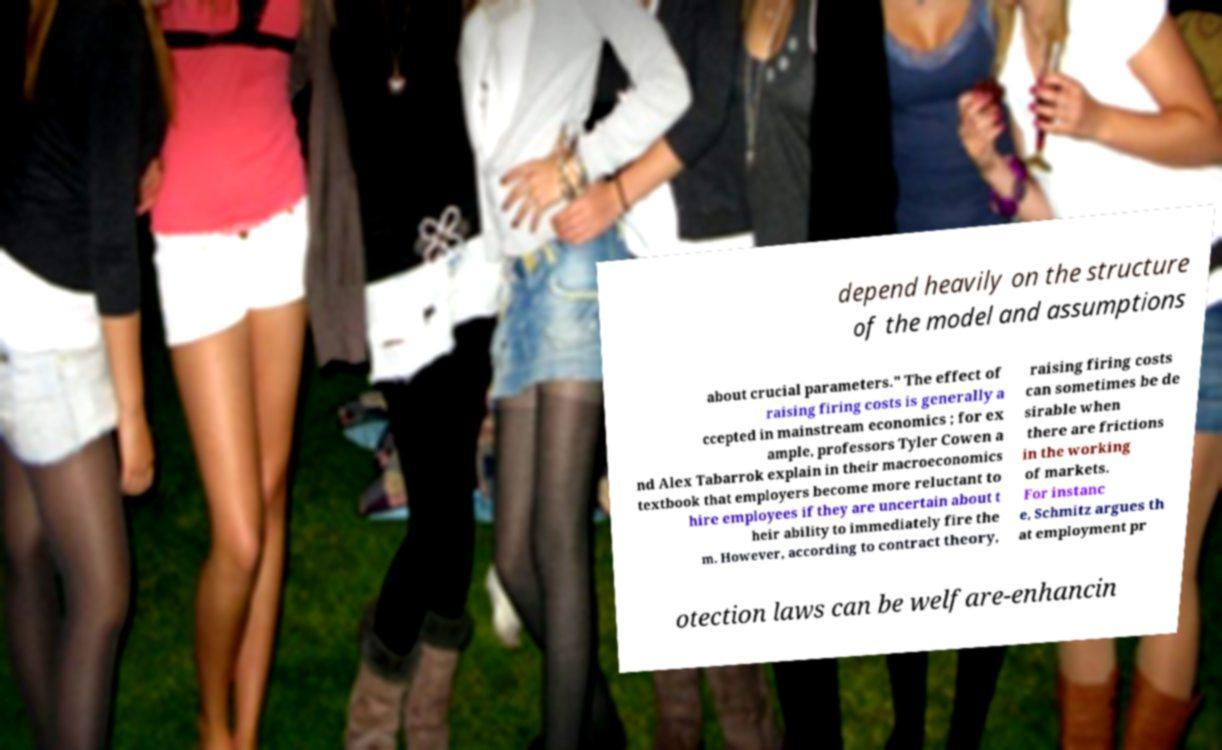What messages or text are displayed in this image? I need them in a readable, typed format. depend heavily on the structure of the model and assumptions about crucial parameters." The effect of raising firing costs is generally a ccepted in mainstream economics ; for ex ample, professors Tyler Cowen a nd Alex Tabarrok explain in their macroeconomics textbook that employers become more reluctant to hire employees if they are uncertain about t heir ability to immediately fire the m. However, according to contract theory, raising firing costs can sometimes be de sirable when there are frictions in the working of markets. For instanc e, Schmitz argues th at employment pr otection laws can be welfare-enhancin 